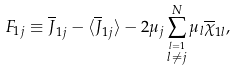Convert formula to latex. <formula><loc_0><loc_0><loc_500><loc_500>F _ { 1 j } \equiv \overline { J } _ { 1 j } - \langle \overline { J } _ { 1 j } \rangle - 2 { \mu } _ { j } \sum _ { \stackrel { l = 1 } { l \neq j } } ^ { N } { \mu } _ { l } \overline { \chi } _ { 1 l } ,</formula> 